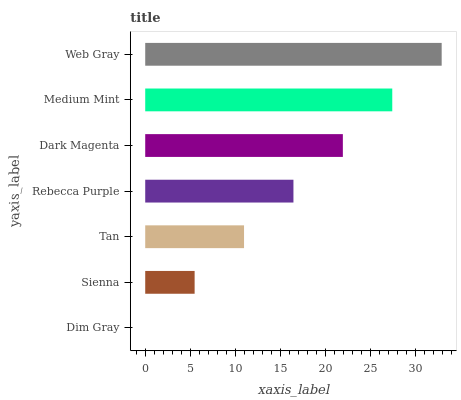Is Dim Gray the minimum?
Answer yes or no. Yes. Is Web Gray the maximum?
Answer yes or no. Yes. Is Sienna the minimum?
Answer yes or no. No. Is Sienna the maximum?
Answer yes or no. No. Is Sienna greater than Dim Gray?
Answer yes or no. Yes. Is Dim Gray less than Sienna?
Answer yes or no. Yes. Is Dim Gray greater than Sienna?
Answer yes or no. No. Is Sienna less than Dim Gray?
Answer yes or no. No. Is Rebecca Purple the high median?
Answer yes or no. Yes. Is Rebecca Purple the low median?
Answer yes or no. Yes. Is Dim Gray the high median?
Answer yes or no. No. Is Tan the low median?
Answer yes or no. No. 